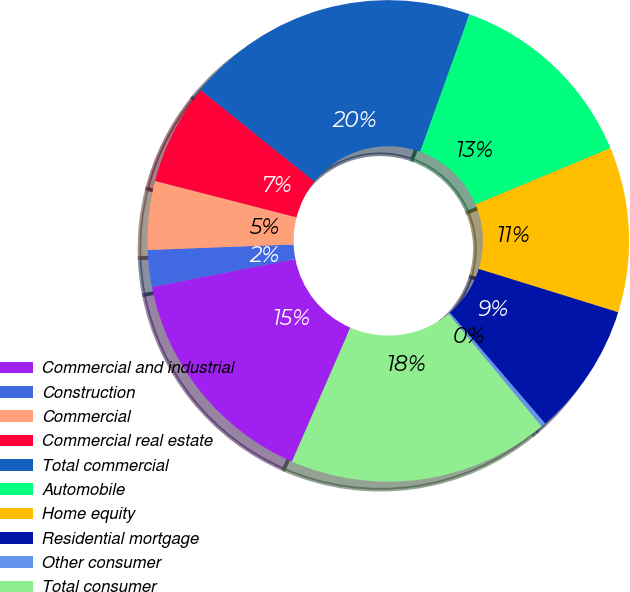<chart> <loc_0><loc_0><loc_500><loc_500><pie_chart><fcel>Commercial and industrial<fcel>Construction<fcel>Commercial<fcel>Commercial real estate<fcel>Total commercial<fcel>Automobile<fcel>Home equity<fcel>Residential mortgage<fcel>Other consumer<fcel>Total consumer<nl><fcel>15.39%<fcel>2.46%<fcel>4.61%<fcel>6.77%<fcel>19.7%<fcel>13.23%<fcel>11.08%<fcel>8.92%<fcel>0.3%<fcel>17.54%<nl></chart> 